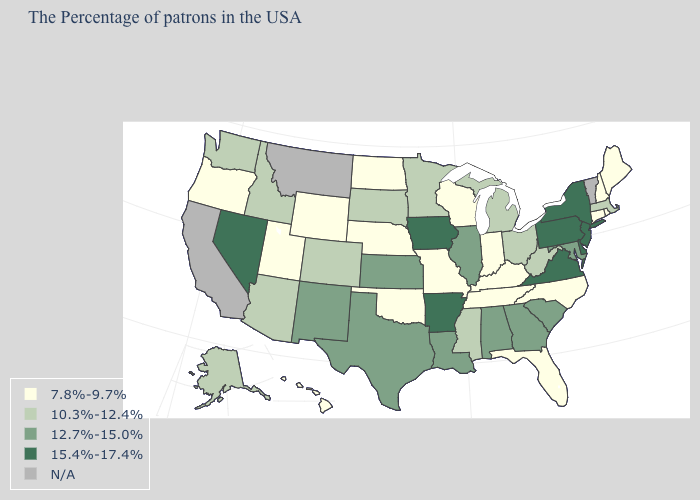Name the states that have a value in the range 10.3%-12.4%?
Short answer required. Massachusetts, West Virginia, Ohio, Michigan, Mississippi, Minnesota, South Dakota, Colorado, Arizona, Idaho, Washington, Alaska. What is the value of Maine?
Be succinct. 7.8%-9.7%. What is the highest value in the USA?
Write a very short answer. 15.4%-17.4%. Which states have the highest value in the USA?
Concise answer only. New York, New Jersey, Delaware, Pennsylvania, Virginia, Arkansas, Iowa, Nevada. Name the states that have a value in the range 7.8%-9.7%?
Quick response, please. Maine, Rhode Island, New Hampshire, Connecticut, North Carolina, Florida, Kentucky, Indiana, Tennessee, Wisconsin, Missouri, Nebraska, Oklahoma, North Dakota, Wyoming, Utah, Oregon, Hawaii. What is the value of Louisiana?
Concise answer only. 12.7%-15.0%. Name the states that have a value in the range 7.8%-9.7%?
Write a very short answer. Maine, Rhode Island, New Hampshire, Connecticut, North Carolina, Florida, Kentucky, Indiana, Tennessee, Wisconsin, Missouri, Nebraska, Oklahoma, North Dakota, Wyoming, Utah, Oregon, Hawaii. What is the highest value in the Northeast ?
Write a very short answer. 15.4%-17.4%. Name the states that have a value in the range N/A?
Concise answer only. Vermont, Montana, California. What is the value of Alabama?
Keep it brief. 12.7%-15.0%. Does New Jersey have the highest value in the USA?
Write a very short answer. Yes. Name the states that have a value in the range 10.3%-12.4%?
Write a very short answer. Massachusetts, West Virginia, Ohio, Michigan, Mississippi, Minnesota, South Dakota, Colorado, Arizona, Idaho, Washington, Alaska. 